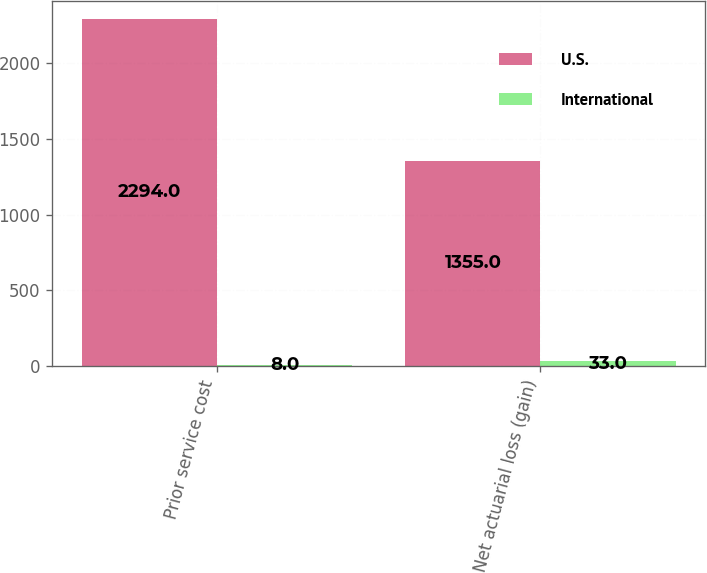<chart> <loc_0><loc_0><loc_500><loc_500><stacked_bar_chart><ecel><fcel>Prior service cost<fcel>Net actuarial loss (gain)<nl><fcel>U.S.<fcel>2294<fcel>1355<nl><fcel>International<fcel>8<fcel>33<nl></chart> 